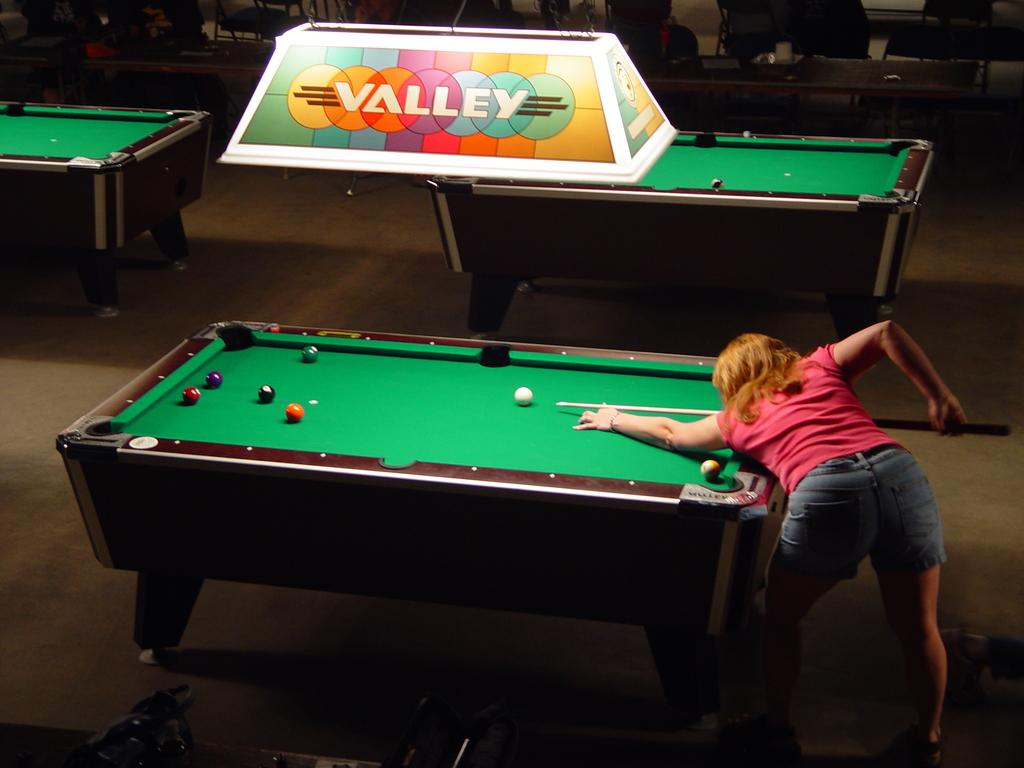Who is the main subject in the image? There is a woman in the image. What is the woman holding in her hands? The woman is holding a stick in her hands. What objects can be seen on the tables in the image? There are balls on the tables. Can you describe the setting where the woman is located? The presence of tables suggests that the woman might be in a room or an indoor setting. What type of road can be seen in the image? There is no road present in the image. How does the woman's pleasure affect the slave in the image? There is no mention of pleasure or a slave in the image; it features a woman holding a stick and tables with balls. 